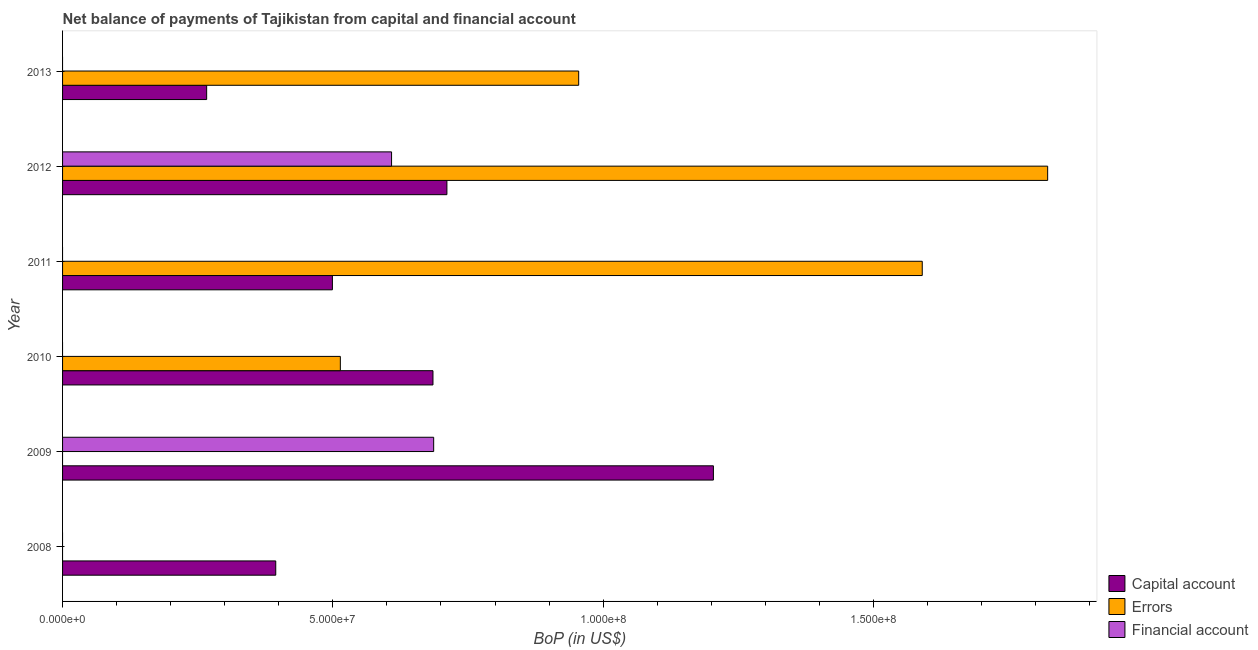How many different coloured bars are there?
Your answer should be compact. 3. How many bars are there on the 1st tick from the bottom?
Ensure brevity in your answer.  1. In how many cases, is the number of bars for a given year not equal to the number of legend labels?
Provide a succinct answer. 5. What is the amount of financial account in 2009?
Keep it short and to the point. 6.87e+07. Across all years, what is the maximum amount of errors?
Keep it short and to the point. 1.82e+08. What is the total amount of errors in the graph?
Provide a succinct answer. 4.88e+08. What is the difference between the amount of errors in 2011 and that in 2013?
Give a very brief answer. 6.36e+07. What is the difference between the amount of errors in 2010 and the amount of net capital account in 2012?
Make the answer very short. -1.97e+07. What is the average amount of errors per year?
Offer a very short reply. 8.14e+07. In the year 2012, what is the difference between the amount of net capital account and amount of errors?
Your answer should be compact. -1.11e+08. In how many years, is the amount of net capital account greater than 70000000 US$?
Offer a terse response. 2. What is the ratio of the amount of errors in 2011 to that in 2013?
Offer a terse response. 1.67. Is the difference between the amount of errors in 2012 and 2013 greater than the difference between the amount of net capital account in 2012 and 2013?
Your answer should be very brief. Yes. What is the difference between the highest and the second highest amount of net capital account?
Give a very brief answer. 4.93e+07. What is the difference between the highest and the lowest amount of net capital account?
Your answer should be very brief. 9.37e+07. Is it the case that in every year, the sum of the amount of net capital account and amount of errors is greater than the amount of financial account?
Provide a short and direct response. Yes. How many bars are there?
Offer a terse response. 12. How many years are there in the graph?
Offer a very short reply. 6. What is the difference between two consecutive major ticks on the X-axis?
Ensure brevity in your answer.  5.00e+07. Are the values on the major ticks of X-axis written in scientific E-notation?
Give a very brief answer. Yes. How are the legend labels stacked?
Offer a very short reply. Vertical. What is the title of the graph?
Make the answer very short. Net balance of payments of Tajikistan from capital and financial account. Does "Ores and metals" appear as one of the legend labels in the graph?
Keep it short and to the point. No. What is the label or title of the X-axis?
Your answer should be very brief. BoP (in US$). What is the BoP (in US$) of Capital account in 2008?
Ensure brevity in your answer.  3.94e+07. What is the BoP (in US$) of Errors in 2008?
Give a very brief answer. 0. What is the BoP (in US$) of Financial account in 2008?
Your answer should be compact. 0. What is the BoP (in US$) of Capital account in 2009?
Provide a short and direct response. 1.20e+08. What is the BoP (in US$) in Financial account in 2009?
Your answer should be compact. 6.87e+07. What is the BoP (in US$) of Capital account in 2010?
Your answer should be very brief. 6.85e+07. What is the BoP (in US$) of Errors in 2010?
Provide a short and direct response. 5.14e+07. What is the BoP (in US$) in Capital account in 2011?
Offer a terse response. 4.99e+07. What is the BoP (in US$) of Errors in 2011?
Give a very brief answer. 1.59e+08. What is the BoP (in US$) in Capital account in 2012?
Provide a succinct answer. 7.11e+07. What is the BoP (in US$) of Errors in 2012?
Your answer should be very brief. 1.82e+08. What is the BoP (in US$) in Financial account in 2012?
Keep it short and to the point. 6.09e+07. What is the BoP (in US$) of Capital account in 2013?
Your answer should be compact. 2.67e+07. What is the BoP (in US$) in Errors in 2013?
Ensure brevity in your answer.  9.55e+07. Across all years, what is the maximum BoP (in US$) in Capital account?
Offer a very short reply. 1.20e+08. Across all years, what is the maximum BoP (in US$) in Errors?
Provide a succinct answer. 1.82e+08. Across all years, what is the maximum BoP (in US$) of Financial account?
Ensure brevity in your answer.  6.87e+07. Across all years, what is the minimum BoP (in US$) of Capital account?
Offer a terse response. 2.67e+07. Across all years, what is the minimum BoP (in US$) of Errors?
Give a very brief answer. 0. What is the total BoP (in US$) of Capital account in the graph?
Offer a terse response. 3.76e+08. What is the total BoP (in US$) in Errors in the graph?
Keep it short and to the point. 4.88e+08. What is the total BoP (in US$) of Financial account in the graph?
Your response must be concise. 1.30e+08. What is the difference between the BoP (in US$) in Capital account in 2008 and that in 2009?
Your response must be concise. -8.10e+07. What is the difference between the BoP (in US$) of Capital account in 2008 and that in 2010?
Provide a short and direct response. -2.91e+07. What is the difference between the BoP (in US$) in Capital account in 2008 and that in 2011?
Your answer should be very brief. -1.05e+07. What is the difference between the BoP (in US$) of Capital account in 2008 and that in 2012?
Ensure brevity in your answer.  -3.17e+07. What is the difference between the BoP (in US$) of Capital account in 2008 and that in 2013?
Your answer should be compact. 1.28e+07. What is the difference between the BoP (in US$) in Capital account in 2009 and that in 2010?
Offer a very short reply. 5.19e+07. What is the difference between the BoP (in US$) in Capital account in 2009 and that in 2011?
Provide a succinct answer. 7.05e+07. What is the difference between the BoP (in US$) in Capital account in 2009 and that in 2012?
Provide a succinct answer. 4.93e+07. What is the difference between the BoP (in US$) in Financial account in 2009 and that in 2012?
Keep it short and to the point. 7.79e+06. What is the difference between the BoP (in US$) of Capital account in 2009 and that in 2013?
Your answer should be compact. 9.37e+07. What is the difference between the BoP (in US$) in Capital account in 2010 and that in 2011?
Provide a succinct answer. 1.86e+07. What is the difference between the BoP (in US$) of Errors in 2010 and that in 2011?
Provide a short and direct response. -1.08e+08. What is the difference between the BoP (in US$) of Capital account in 2010 and that in 2012?
Offer a terse response. -2.58e+06. What is the difference between the BoP (in US$) of Errors in 2010 and that in 2012?
Your answer should be very brief. -1.31e+08. What is the difference between the BoP (in US$) of Capital account in 2010 and that in 2013?
Offer a terse response. 4.19e+07. What is the difference between the BoP (in US$) in Errors in 2010 and that in 2013?
Offer a terse response. -4.41e+07. What is the difference between the BoP (in US$) in Capital account in 2011 and that in 2012?
Offer a terse response. -2.12e+07. What is the difference between the BoP (in US$) of Errors in 2011 and that in 2012?
Your answer should be compact. -2.32e+07. What is the difference between the BoP (in US$) in Capital account in 2011 and that in 2013?
Keep it short and to the point. 2.33e+07. What is the difference between the BoP (in US$) in Errors in 2011 and that in 2013?
Make the answer very short. 6.36e+07. What is the difference between the BoP (in US$) in Capital account in 2012 and that in 2013?
Make the answer very short. 4.44e+07. What is the difference between the BoP (in US$) of Errors in 2012 and that in 2013?
Your answer should be very brief. 8.68e+07. What is the difference between the BoP (in US$) of Capital account in 2008 and the BoP (in US$) of Financial account in 2009?
Your answer should be compact. -2.92e+07. What is the difference between the BoP (in US$) of Capital account in 2008 and the BoP (in US$) of Errors in 2010?
Offer a terse response. -1.20e+07. What is the difference between the BoP (in US$) of Capital account in 2008 and the BoP (in US$) of Errors in 2011?
Offer a terse response. -1.20e+08. What is the difference between the BoP (in US$) of Capital account in 2008 and the BoP (in US$) of Errors in 2012?
Ensure brevity in your answer.  -1.43e+08. What is the difference between the BoP (in US$) in Capital account in 2008 and the BoP (in US$) in Financial account in 2012?
Give a very brief answer. -2.14e+07. What is the difference between the BoP (in US$) in Capital account in 2008 and the BoP (in US$) in Errors in 2013?
Give a very brief answer. -5.60e+07. What is the difference between the BoP (in US$) in Capital account in 2009 and the BoP (in US$) in Errors in 2010?
Ensure brevity in your answer.  6.90e+07. What is the difference between the BoP (in US$) of Capital account in 2009 and the BoP (in US$) of Errors in 2011?
Your answer should be compact. -3.86e+07. What is the difference between the BoP (in US$) in Capital account in 2009 and the BoP (in US$) in Errors in 2012?
Offer a very short reply. -6.18e+07. What is the difference between the BoP (in US$) in Capital account in 2009 and the BoP (in US$) in Financial account in 2012?
Keep it short and to the point. 5.95e+07. What is the difference between the BoP (in US$) of Capital account in 2009 and the BoP (in US$) of Errors in 2013?
Keep it short and to the point. 2.49e+07. What is the difference between the BoP (in US$) in Capital account in 2010 and the BoP (in US$) in Errors in 2011?
Provide a short and direct response. -9.05e+07. What is the difference between the BoP (in US$) of Capital account in 2010 and the BoP (in US$) of Errors in 2012?
Keep it short and to the point. -1.14e+08. What is the difference between the BoP (in US$) of Capital account in 2010 and the BoP (in US$) of Financial account in 2012?
Ensure brevity in your answer.  7.66e+06. What is the difference between the BoP (in US$) in Errors in 2010 and the BoP (in US$) in Financial account in 2012?
Your answer should be very brief. -9.48e+06. What is the difference between the BoP (in US$) of Capital account in 2010 and the BoP (in US$) of Errors in 2013?
Ensure brevity in your answer.  -2.70e+07. What is the difference between the BoP (in US$) in Capital account in 2011 and the BoP (in US$) in Errors in 2012?
Your answer should be compact. -1.32e+08. What is the difference between the BoP (in US$) of Capital account in 2011 and the BoP (in US$) of Financial account in 2012?
Make the answer very short. -1.09e+07. What is the difference between the BoP (in US$) of Errors in 2011 and the BoP (in US$) of Financial account in 2012?
Offer a very short reply. 9.82e+07. What is the difference between the BoP (in US$) in Capital account in 2011 and the BoP (in US$) in Errors in 2013?
Offer a very short reply. -4.56e+07. What is the difference between the BoP (in US$) in Capital account in 2012 and the BoP (in US$) in Errors in 2013?
Ensure brevity in your answer.  -2.44e+07. What is the average BoP (in US$) in Capital account per year?
Your answer should be very brief. 6.27e+07. What is the average BoP (in US$) of Errors per year?
Make the answer very short. 8.14e+07. What is the average BoP (in US$) of Financial account per year?
Provide a short and direct response. 2.16e+07. In the year 2009, what is the difference between the BoP (in US$) of Capital account and BoP (in US$) of Financial account?
Keep it short and to the point. 5.18e+07. In the year 2010, what is the difference between the BoP (in US$) of Capital account and BoP (in US$) of Errors?
Keep it short and to the point. 1.71e+07. In the year 2011, what is the difference between the BoP (in US$) in Capital account and BoP (in US$) in Errors?
Your answer should be very brief. -1.09e+08. In the year 2012, what is the difference between the BoP (in US$) of Capital account and BoP (in US$) of Errors?
Provide a succinct answer. -1.11e+08. In the year 2012, what is the difference between the BoP (in US$) in Capital account and BoP (in US$) in Financial account?
Provide a succinct answer. 1.02e+07. In the year 2012, what is the difference between the BoP (in US$) in Errors and BoP (in US$) in Financial account?
Offer a very short reply. 1.21e+08. In the year 2013, what is the difference between the BoP (in US$) of Capital account and BoP (in US$) of Errors?
Ensure brevity in your answer.  -6.88e+07. What is the ratio of the BoP (in US$) in Capital account in 2008 to that in 2009?
Provide a succinct answer. 0.33. What is the ratio of the BoP (in US$) in Capital account in 2008 to that in 2010?
Offer a terse response. 0.58. What is the ratio of the BoP (in US$) of Capital account in 2008 to that in 2011?
Provide a succinct answer. 0.79. What is the ratio of the BoP (in US$) of Capital account in 2008 to that in 2012?
Give a very brief answer. 0.55. What is the ratio of the BoP (in US$) in Capital account in 2008 to that in 2013?
Offer a terse response. 1.48. What is the ratio of the BoP (in US$) of Capital account in 2009 to that in 2010?
Make the answer very short. 1.76. What is the ratio of the BoP (in US$) in Capital account in 2009 to that in 2011?
Provide a succinct answer. 2.41. What is the ratio of the BoP (in US$) in Capital account in 2009 to that in 2012?
Provide a short and direct response. 1.69. What is the ratio of the BoP (in US$) of Financial account in 2009 to that in 2012?
Provide a short and direct response. 1.13. What is the ratio of the BoP (in US$) of Capital account in 2009 to that in 2013?
Offer a very short reply. 4.52. What is the ratio of the BoP (in US$) of Capital account in 2010 to that in 2011?
Make the answer very short. 1.37. What is the ratio of the BoP (in US$) in Errors in 2010 to that in 2011?
Give a very brief answer. 0.32. What is the ratio of the BoP (in US$) of Capital account in 2010 to that in 2012?
Offer a terse response. 0.96. What is the ratio of the BoP (in US$) in Errors in 2010 to that in 2012?
Offer a very short reply. 0.28. What is the ratio of the BoP (in US$) in Capital account in 2010 to that in 2013?
Make the answer very short. 2.57. What is the ratio of the BoP (in US$) of Errors in 2010 to that in 2013?
Ensure brevity in your answer.  0.54. What is the ratio of the BoP (in US$) in Capital account in 2011 to that in 2012?
Provide a succinct answer. 0.7. What is the ratio of the BoP (in US$) in Errors in 2011 to that in 2012?
Your answer should be compact. 0.87. What is the ratio of the BoP (in US$) in Capital account in 2011 to that in 2013?
Your response must be concise. 1.87. What is the ratio of the BoP (in US$) of Errors in 2011 to that in 2013?
Offer a very short reply. 1.67. What is the ratio of the BoP (in US$) in Capital account in 2012 to that in 2013?
Offer a terse response. 2.67. What is the ratio of the BoP (in US$) in Errors in 2012 to that in 2013?
Give a very brief answer. 1.91. What is the difference between the highest and the second highest BoP (in US$) of Capital account?
Offer a very short reply. 4.93e+07. What is the difference between the highest and the second highest BoP (in US$) in Errors?
Make the answer very short. 2.32e+07. What is the difference between the highest and the lowest BoP (in US$) of Capital account?
Provide a succinct answer. 9.37e+07. What is the difference between the highest and the lowest BoP (in US$) in Errors?
Make the answer very short. 1.82e+08. What is the difference between the highest and the lowest BoP (in US$) in Financial account?
Keep it short and to the point. 6.87e+07. 